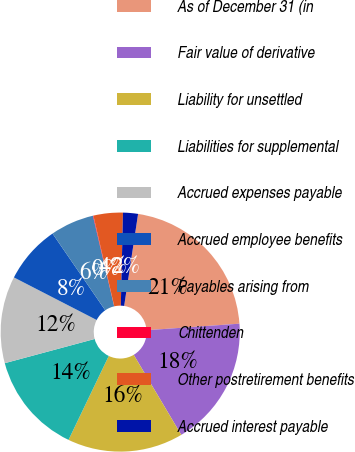<chart> <loc_0><loc_0><loc_500><loc_500><pie_chart><fcel>As of December 31 (in<fcel>Fair value of derivative<fcel>Liability for unsettled<fcel>Liabilities for supplemental<fcel>Accrued expenses payable<fcel>Accrued employee benefits<fcel>Payables arising from<fcel>Chittenden<fcel>Other postretirement benefits<fcel>Accrued interest payable<nl><fcel>21.49%<fcel>17.59%<fcel>15.65%<fcel>13.7%<fcel>11.75%<fcel>7.86%<fcel>5.91%<fcel>0.07%<fcel>3.97%<fcel>2.02%<nl></chart> 